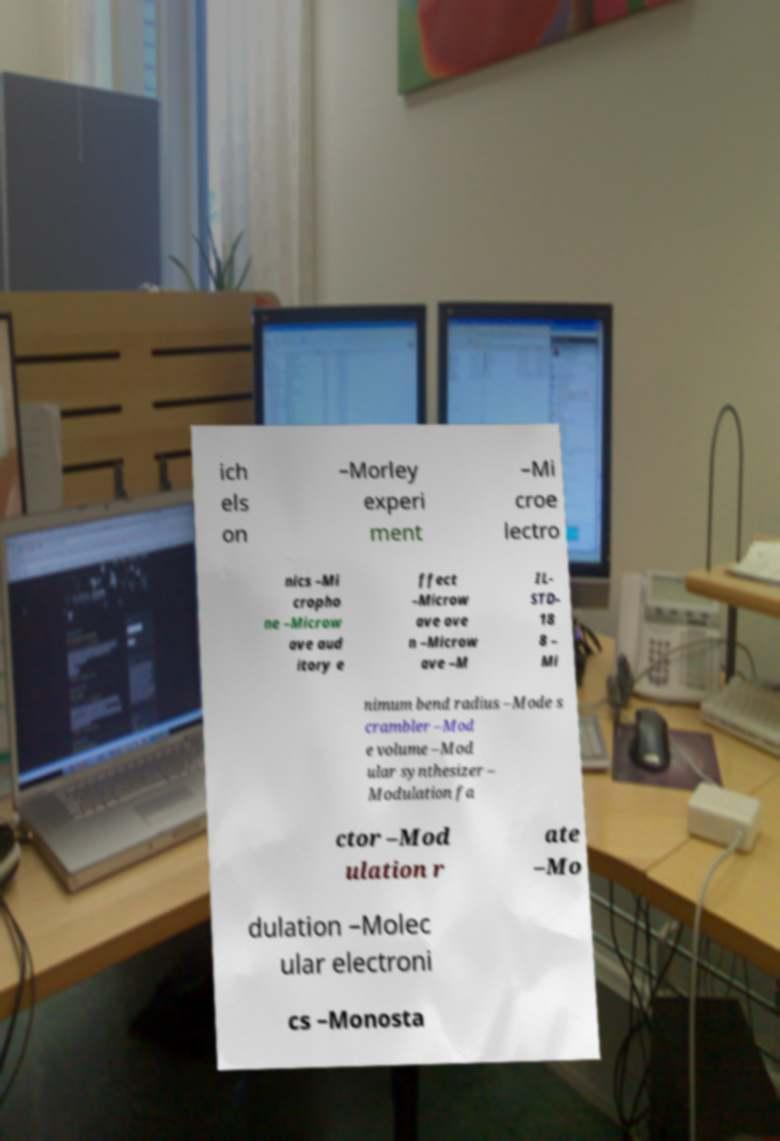Could you assist in decoding the text presented in this image and type it out clearly? ich els on –Morley experi ment –Mi croe lectro nics –Mi cropho ne –Microw ave aud itory e ffect –Microw ave ove n –Microw ave –M IL- STD- 18 8 – Mi nimum bend radius –Mode s crambler –Mod e volume –Mod ular synthesizer – Modulation fa ctor –Mod ulation r ate –Mo dulation –Molec ular electroni cs –Monosta 